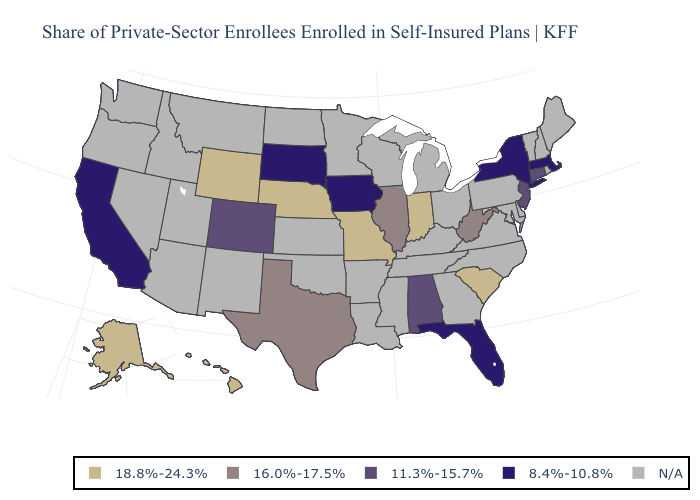What is the value of Nevada?
Quick response, please. N/A. What is the value of Florida?
Write a very short answer. 8.4%-10.8%. What is the highest value in states that border Florida?
Short answer required. 11.3%-15.7%. Name the states that have a value in the range N/A?
Short answer required. Arizona, Arkansas, Delaware, Georgia, Idaho, Kansas, Kentucky, Louisiana, Maine, Maryland, Michigan, Minnesota, Mississippi, Montana, Nevada, New Hampshire, New Mexico, North Carolina, North Dakota, Ohio, Oklahoma, Oregon, Pennsylvania, Rhode Island, Tennessee, Utah, Vermont, Virginia, Washington, Wisconsin. Does Hawaii have the highest value in the USA?
Keep it brief. Yes. Among the states that border Wisconsin , does Illinois have the lowest value?
Answer briefly. No. What is the lowest value in states that border Rhode Island?
Give a very brief answer. 8.4%-10.8%. What is the value of Oklahoma?
Be succinct. N/A. Name the states that have a value in the range 11.3%-15.7%?
Concise answer only. Alabama, Colorado, Connecticut, New Jersey. What is the highest value in states that border Missouri?
Write a very short answer. 18.8%-24.3%. What is the highest value in the USA?
Be succinct. 18.8%-24.3%. What is the value of California?
Keep it brief. 8.4%-10.8%. What is the value of Arizona?
Short answer required. N/A. How many symbols are there in the legend?
Keep it brief. 5. 